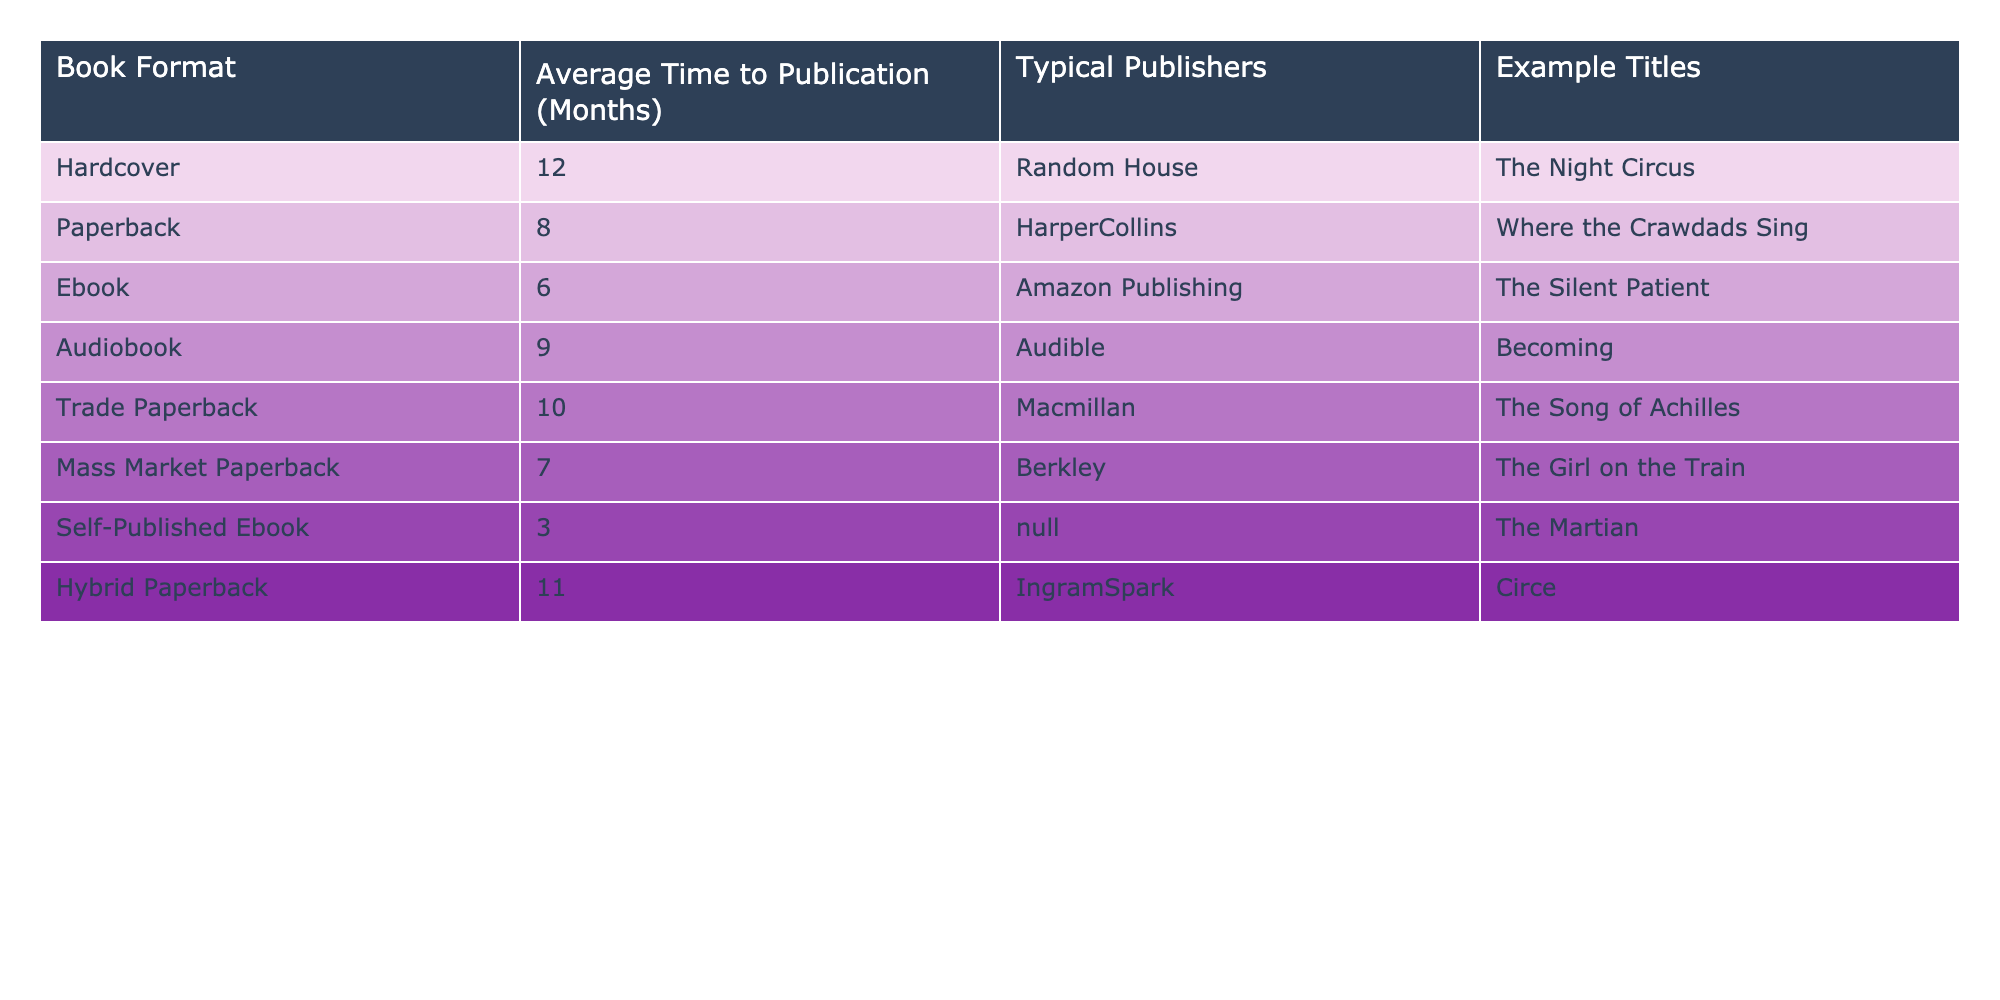What is the average time to publication for hardcover books? The table shows that the average time to publication for hardcover books is 12 months.
Answer: 12 months Which book format has the shortest average time to publication? According to the table, self-published ebooks have the shortest average time at 3 months.
Answer: Self-published ebook How many months does it take on average to publish a paperback compared to a hardcover? The average time for a paperback is 8 months, while for a hardcover, it is 12 months. The difference is 12 - 8 = 4 months.
Answer: 4 months Is it true that audiobooks take less time to publish than trade paperbacks? The average time to publish an audiobook is 9 months, whereas trade paperbacks take 10 months, indicating that it is false that audiobooks take less time.
Answer: False What is the average time to publication for ebooks and mass market paperbacks combined? The average for ebooks is 6 months and for mass market paperbacks is 7 months. The total is 6 + 7 = 13 months, and there are 2 formats, so the average is 13/2 = 6.5 months.
Answer: 6.5 months Which publisher is associated with the book format that has the maximum average time to publication? The maximum average time is for hardcover books at 12 months, associated with Random House.
Answer: Random House If a hybrid paperback takes 11 months to publish, how much longer is that than an ebook? Hybrid paperbacks take 11 months, and ebooks take 6 months. The difference is 11 - 6 = 5 months, indicating that hybrid paperbacks take 5 months longer.
Answer: 5 months How many formats take less than 10 months to publish? The table lists three formats with average times less than 10 months: ebook (6), mass market paperback (7), and paperback (8), making a total of 4 formats.
Answer: 4 formats What is the average time to publication for printed formats (hardcover, paperback, trade paperback, mass market paperback, and hybrid paperback)? Adding the averages: 12 (hardcover) + 8 (paperback) + 10 (trade paperback) + 7 (mass market) + 11 (hybrid) equals 48 months, divided by 5 formats gives an average of 48/5 = 9.6 months.
Answer: 9.6 months Are there any formats that take exactly 9 months to publish? The data shows that audiobooks take 9 months, indicating that there is one format that aligns with that criterion.
Answer: Yes 